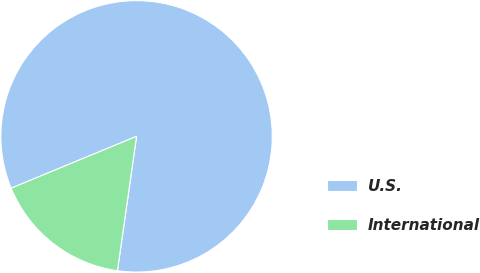<chart> <loc_0><loc_0><loc_500><loc_500><pie_chart><fcel>U.S.<fcel>International<nl><fcel>83.49%<fcel>16.51%<nl></chart> 